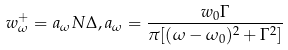Convert formula to latex. <formula><loc_0><loc_0><loc_500><loc_500>w ^ { + } _ { \omega } = a _ { \omega } N \Delta , a _ { \omega } = \frac { w _ { 0 } \Gamma } { \pi [ ( \omega - \omega _ { 0 } ) ^ { 2 } + \Gamma ^ { 2 } ] }</formula> 